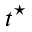Convert formula to latex. <formula><loc_0><loc_0><loc_500><loc_500>t ^ { ^ { * } }</formula> 